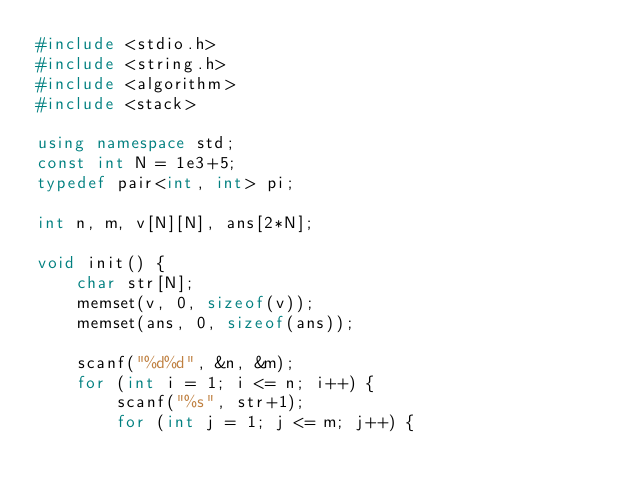<code> <loc_0><loc_0><loc_500><loc_500><_C++_>#include <stdio.h>
#include <string.h>
#include <algorithm>
#include <stack>

using namespace std;
const int N = 1e3+5;
typedef pair<int, int> pi;

int n, m, v[N][N], ans[2*N];

void init() {
	char str[N];
	memset(v, 0, sizeof(v));
	memset(ans, 0, sizeof(ans));

	scanf("%d%d", &n, &m);
	for (int i = 1; i <= n; i++) {
		scanf("%s", str+1);
		for (int j = 1; j <= m; j++) {</code> 